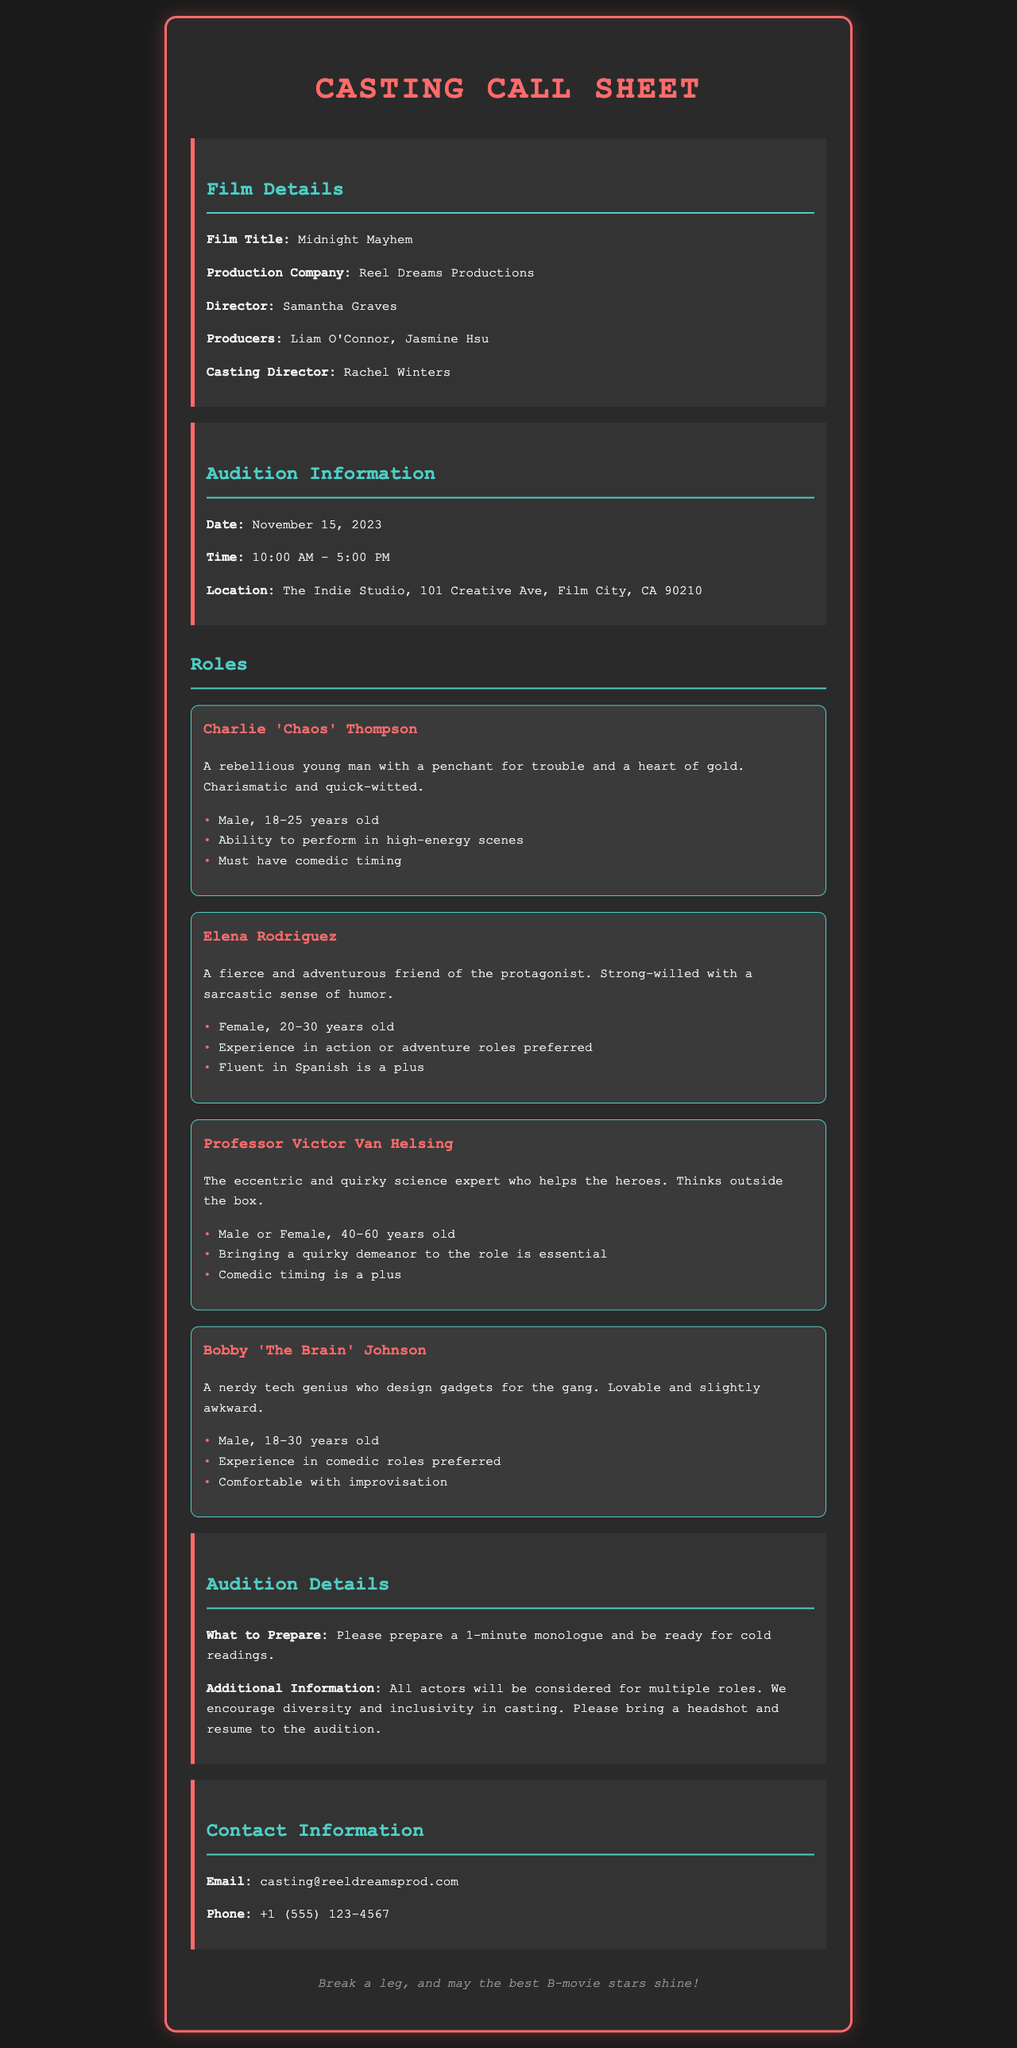what is the film title? The film title is directly stated in the document under Film Details.
Answer: Midnight Mayhem who is the director? The director's name is provided in the Film Details section.
Answer: Samantha Graves what is the date of the auditions? The date can be found in the Audition Information section.
Answer: November 15, 2023 how old should Charlie 'Chaos' Thompson be? The age range for Charlie is specified in the role details.
Answer: 18-25 years old what is required for the audition preparation? This information is detailed under Audition Details.
Answer: 1-minute monologue what is the contact email for casting inquiries? The contact email is listed in the Contact Information section.
Answer: casting@reeldreamsprod.com which role requires fluency in Spanish? The requirement for fluency in Spanish is associated with one specific character in the roles section.
Answer: Elena Rodriguez how should the audition candidates emphasize diversity? This is highlighted in the Additional Information under Audition Details where inclusivity is mentioned.
Answer: Encourage diversity and inclusivity which role is designed for a character with a quirky demeanor? The characteristic is explicitly mentioned in the role details of one character.
Answer: Professor Victor Van Helsing 